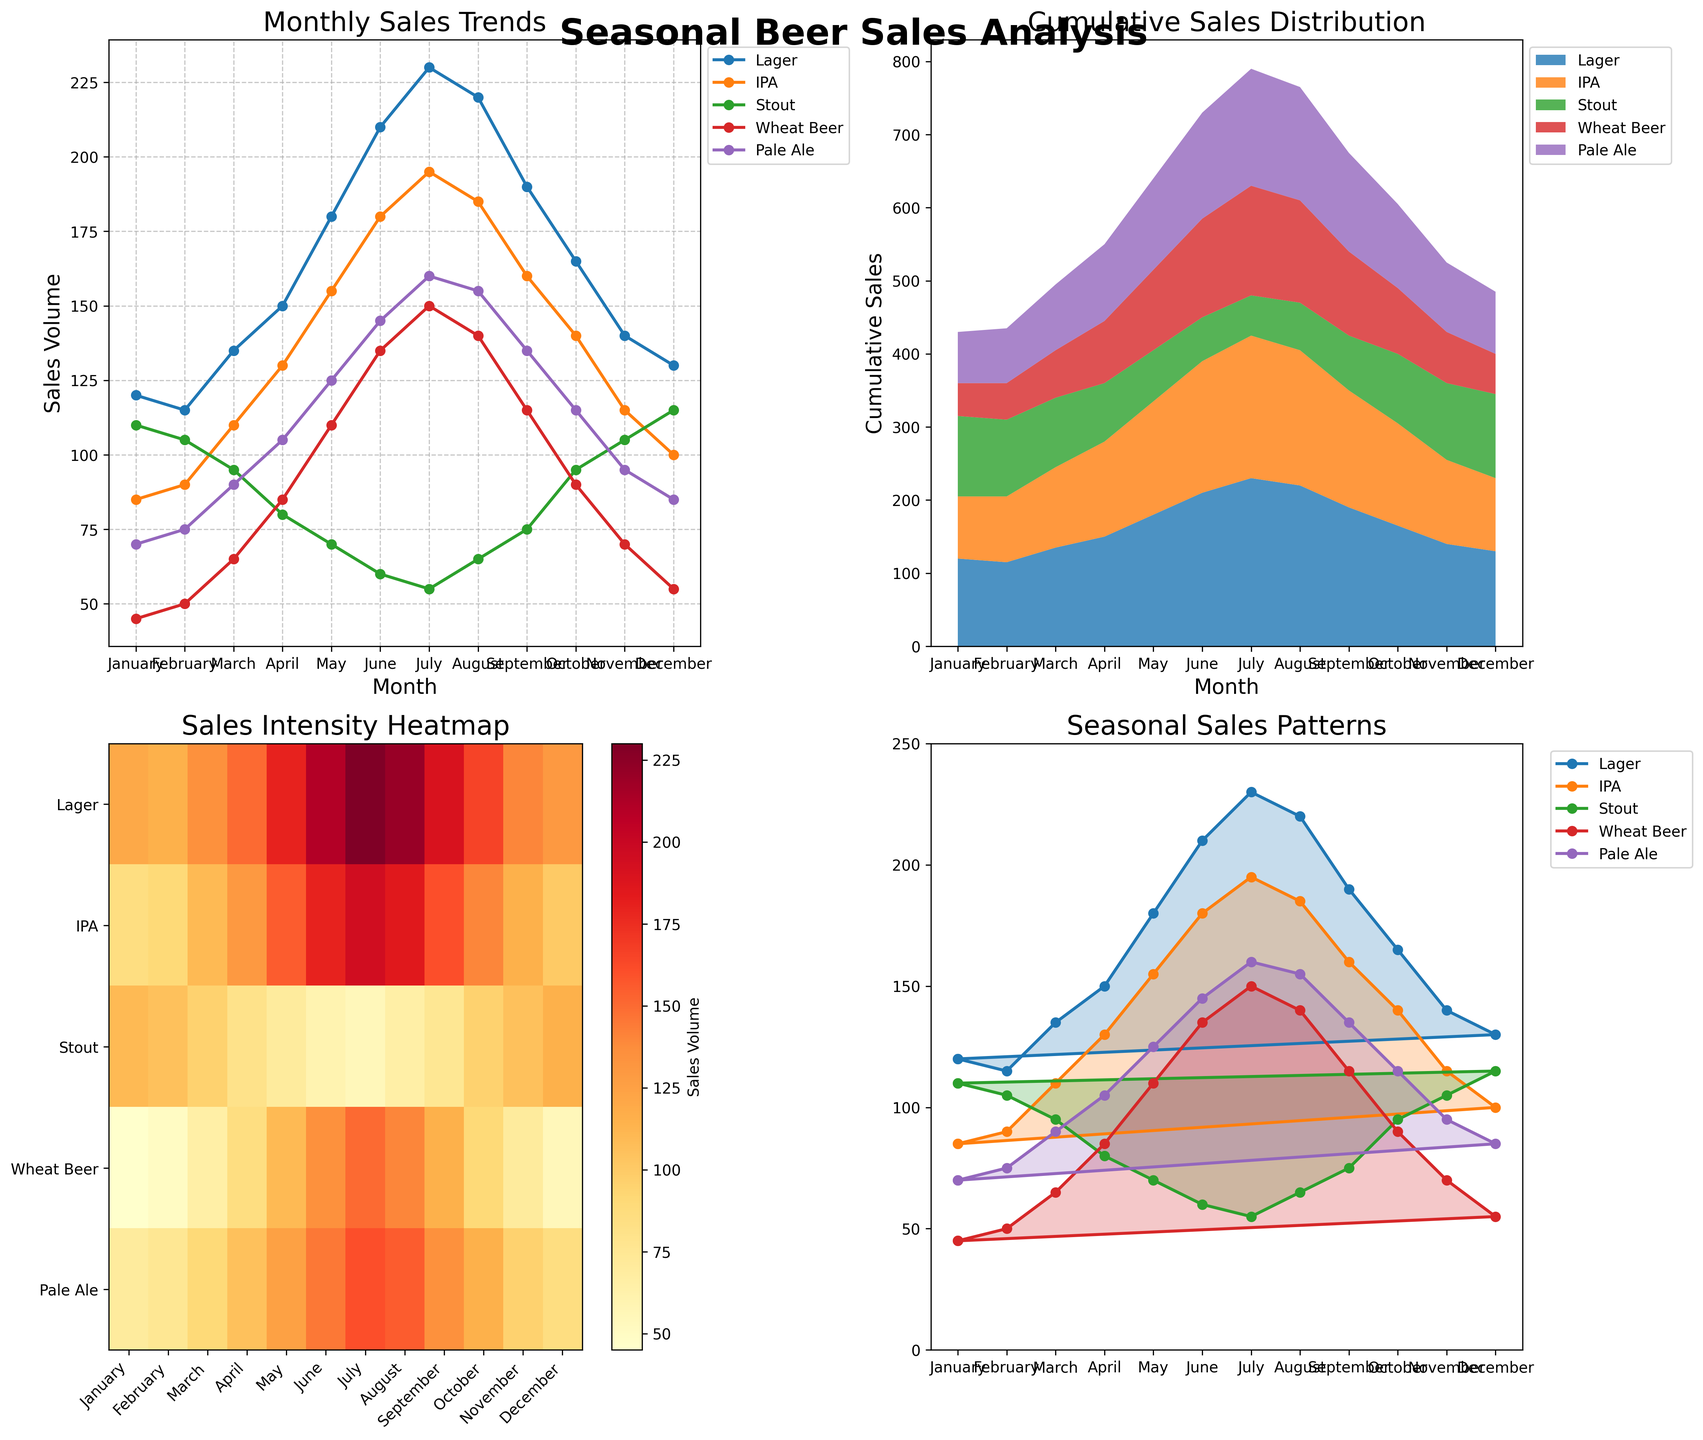What month shows the highest sales volume for Lagers? The line plot in the top-left subplot shows monthly sales trends. By observing the Lager line, the peak point is in July.
Answer: July How do Lager sales in January compare to those in December? In the line plot, the Lager sales in January are marked at 120 units while in December they are marked at 130 units, making December's sales higher by 10 units.
Answer: December sales are 10 units higher What's the total sales volume for IPAs in the first quarter of the year (January to March)? To find the total sales volume for IPAs in January, February, and March, sum the values: 85 (Jan) + 90 (Feb) + 110 (Mar) = 285.
Answer: 285 Which beer style has the smallest seasonal variability based on the radar chart? The radar chart shows that 'Stout' has the least variation compared to others, as its shape appears the most consistent and less spiky throughout the months.
Answer: Stout In which month do all the beer styles combined have the highest cumulative sales? Refer to the stacked area chart for highest peak. In July, the sum of all beer sales is the highest.
Answer: July What's the difference between the maximum and minimum monthly sales volumes for Wheat Beer? From the line plot, maximum sales for Wheat Beer are in July (150) and minimum is in January (45). So, the difference is 150 - 45 = 105.
Answer: 105 How does the sales pattern of Pale Ale in April compare to that of November? The sales for Pale Ale in April are 105 units, while in November it is 95 units. Consequently, April records higher sales by 10 units.
Answer: April sales are 10 units higher Which beer style appears to have the highest intensity (darkest color) in the heatmap? The Lager row in the heatmap shows the darkest shades, indicating higher sales volumes throughout the year.
Answer: Lager What's the average monthly sales volume of Stout? Add all monthly sales volumes for Stout: 110 + 105 + 95 + 80 + 70 + 60 + 55 + 65 + 75 + 95 + 105 + 115 = 1030. Then divide by 12: 1030/12 ≈ 85.83.
Answer: 85.83 